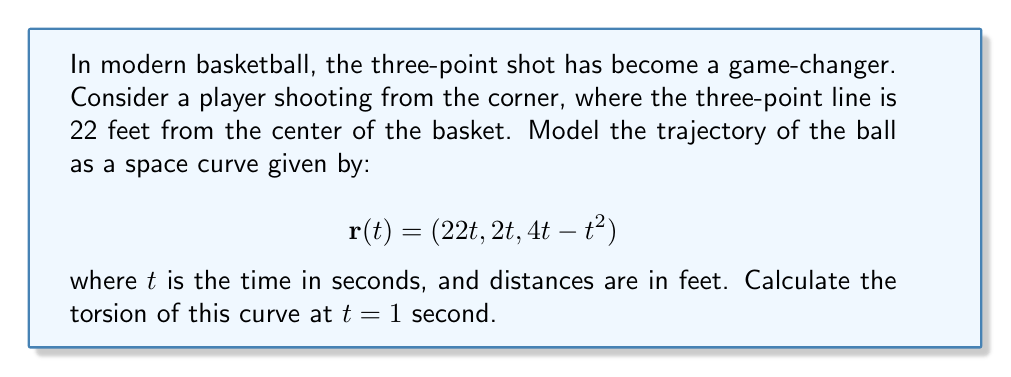Solve this math problem. To calculate the torsion of the space curve, we'll follow these steps:

1) First, we need to calculate $\mathbf{r}'(t)$, $\mathbf{r}''(t)$, and $\mathbf{r}'''(t)$:

   $$\mathbf{r}'(t) = (22, 2, 4-2t)$$
   $$\mathbf{r}''(t) = (0, 0, -2)$$
   $$\mathbf{r}'''(t) = (0, 0, 0)$$

2) The torsion $\tau$ is given by the formula:

   $$\tau = \frac{(\mathbf{r}' \times \mathbf{r}'') \cdot \mathbf{r}'''}{|\mathbf{r}' \times \mathbf{r}''|^2}$$

3) Let's calculate $\mathbf{r}' \times \mathbf{r}''$:

   $$\mathbf{r}' \times \mathbf{r}'' = \begin{vmatrix} 
   \mathbf{i} & \mathbf{j} & \mathbf{k} \\
   22 & 2 & 4-2t \\
   0 & 0 & -2
   \end{vmatrix} = (-4, 44, 0)$$

4) Now, $(\mathbf{r}' \times \mathbf{r}'') \cdot \mathbf{r}''' = 0$ because $\mathbf{r}'''(t) = (0, 0, 0)$

5) Therefore, the torsion $\tau = 0$ for all $t$, including at $t = 1$.

This result indicates that the trajectory of the ball lies entirely in a plane, which is consistent with the parabolic path we typically observe in basketball shots.
Answer: $\tau = 0$ 